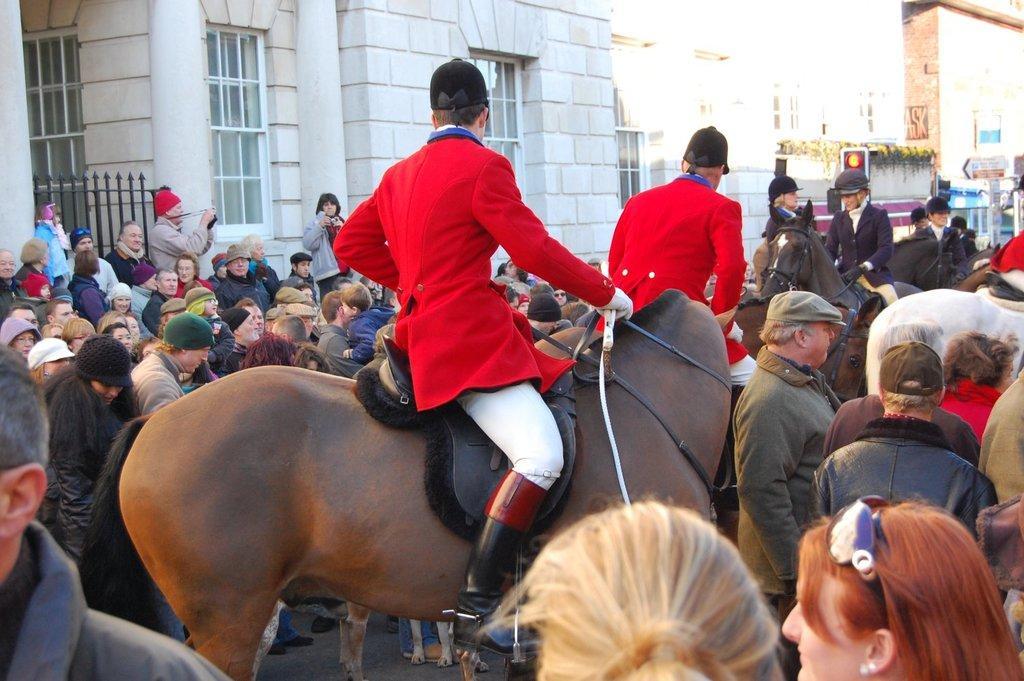How would you summarize this image in a sentence or two? Few people are sitting on horses. There are some people gathered around them. 